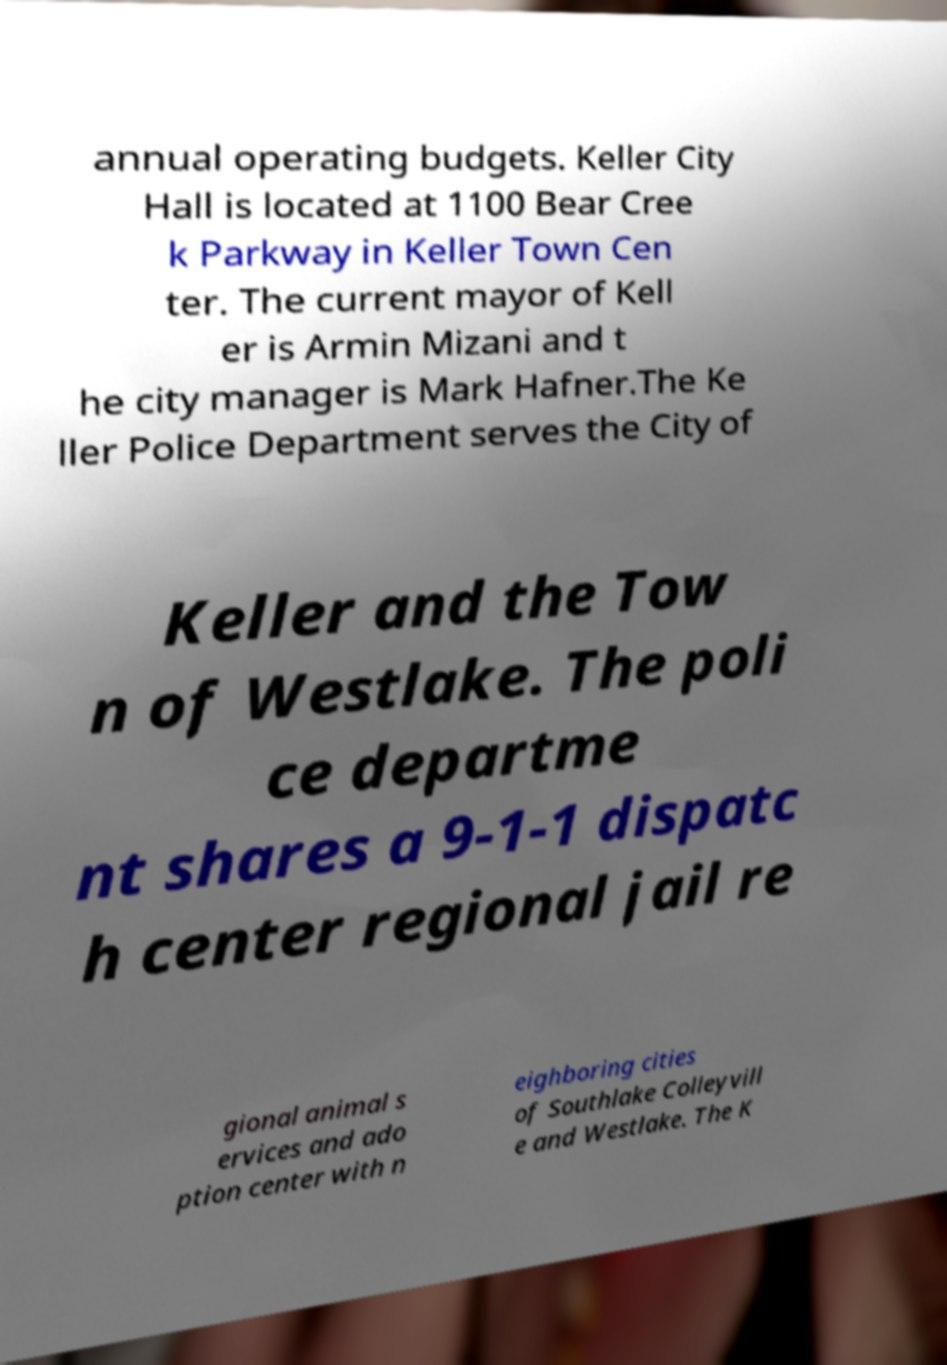Please read and relay the text visible in this image. What does it say? annual operating budgets. Keller City Hall is located at 1100 Bear Cree k Parkway in Keller Town Cen ter. The current mayor of Kell er is Armin Mizani and t he city manager is Mark Hafner.The Ke ller Police Department serves the City of Keller and the Tow n of Westlake. The poli ce departme nt shares a 9-1-1 dispatc h center regional jail re gional animal s ervices and ado ption center with n eighboring cities of Southlake Colleyvill e and Westlake. The K 